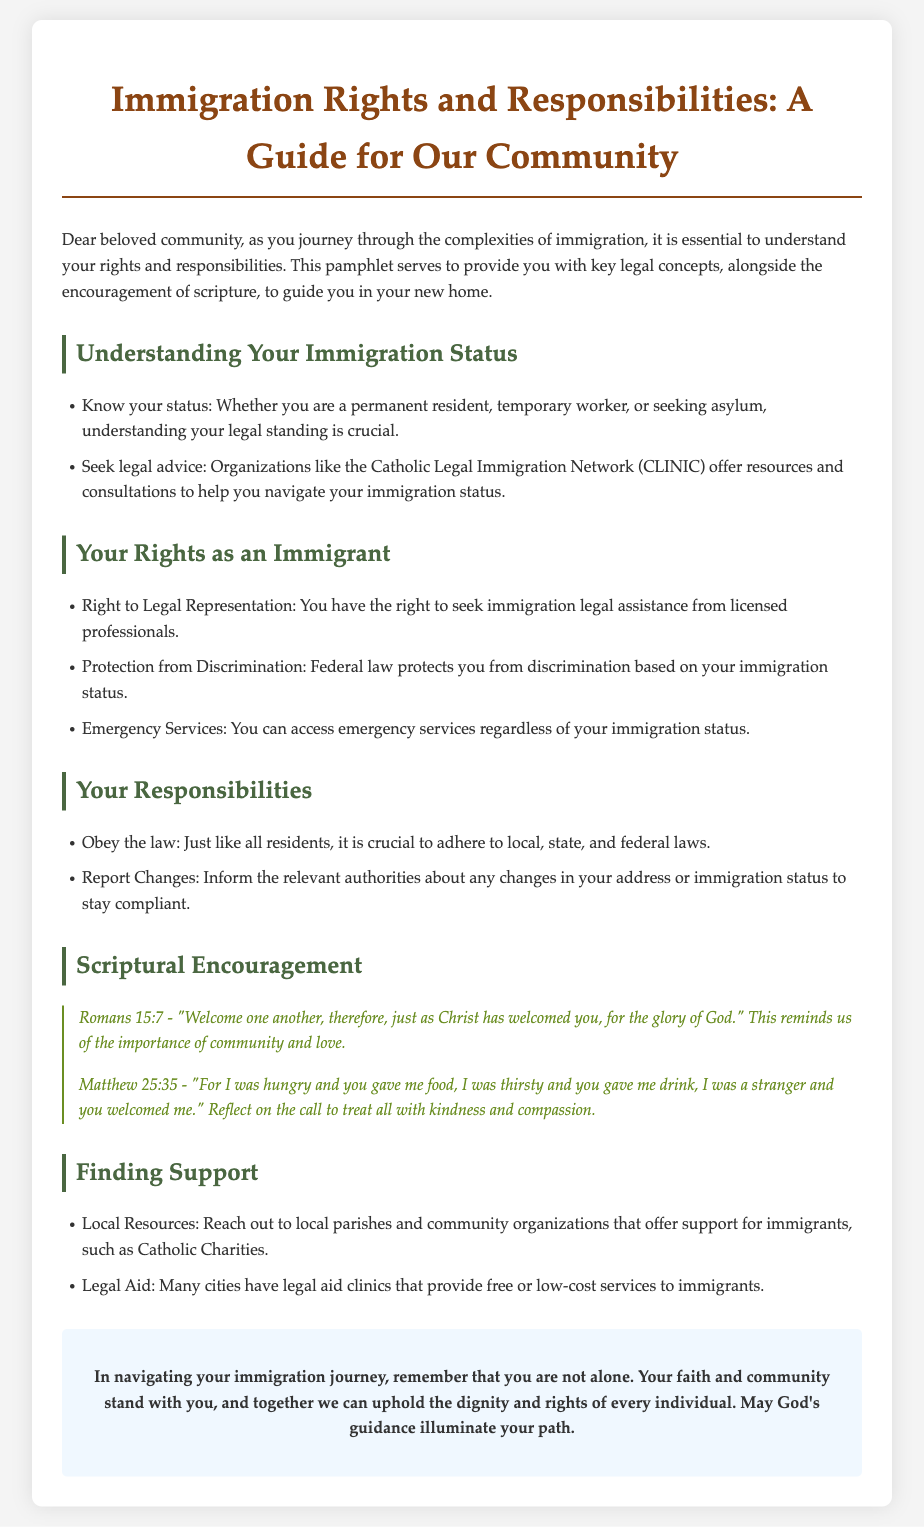What is the title of the guide? The title of the guide reflects its primary focus on immigration rights and responsibilities, which is stated at the beginning of the document.
Answer: Immigration Rights and Responsibilities: A Guide for Our Community What organization offers resources for legal advice? The document specifically mentions this organization as a resource for seeking legal advice regarding immigration status.
Answer: Catholic Legal Immigration Network (CLINIC) What scripture verse emphasizes welcoming one another? This verse is cited in the section that offers scriptural encouragement and emphasizes the importance of community and love.
Answer: Romans 15:7 What is one of the rights you have as an immigrant? This question refers to a specific legal right listed in the document regarding legal representation.
Answer: Right to Legal Representation What is a responsibility mentioned for immigrants? The document outlines that immigrants should adhere to laws, which is categorized as a responsibility they hold.
Answer: Obey the law How many scriptural references are provided? The document lists the number of scriptural references included in the encouragement section.
Answer: Two What type of support does the guide suggest finding? This question pertains to the general category of resources discussed in the guide for immigrants seeking aid.
Answer: Support for immigrants Which verse reflects the call to treat others with kindness? This question asks for the verse that illustrates the compassionate treatment of others, found in the scriptural encouragement section.
Answer: Matthew 25:35 